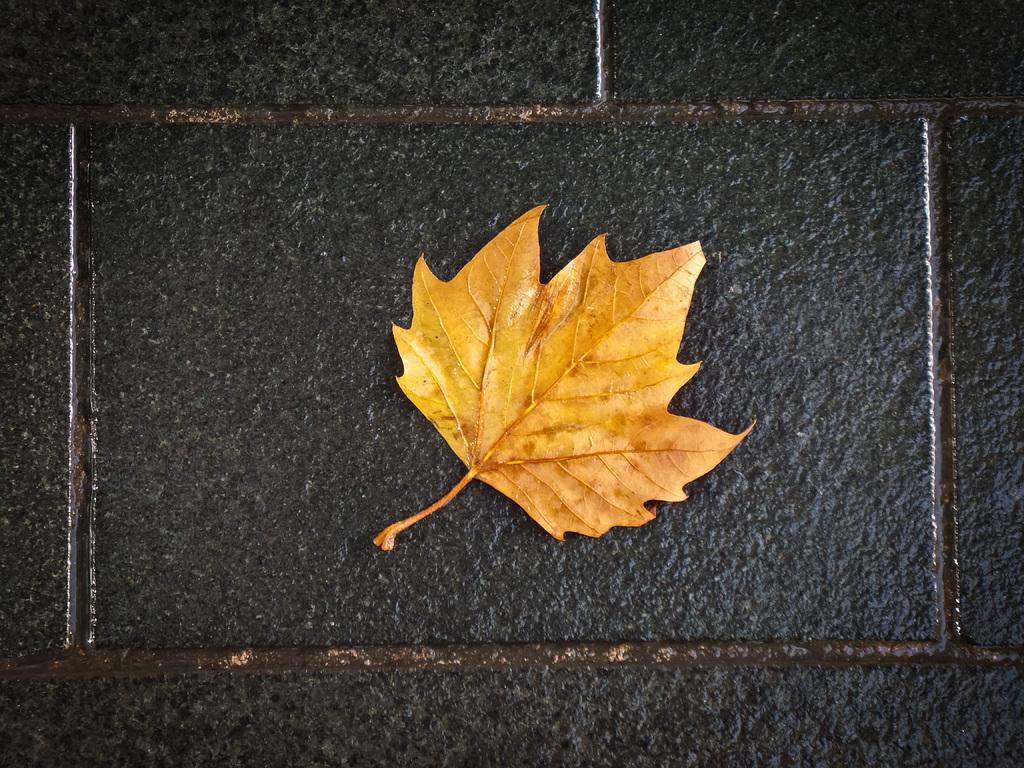How would you summarize this image in a sentence or two? In the image I can see a yellow color leaf on a black color surface. 